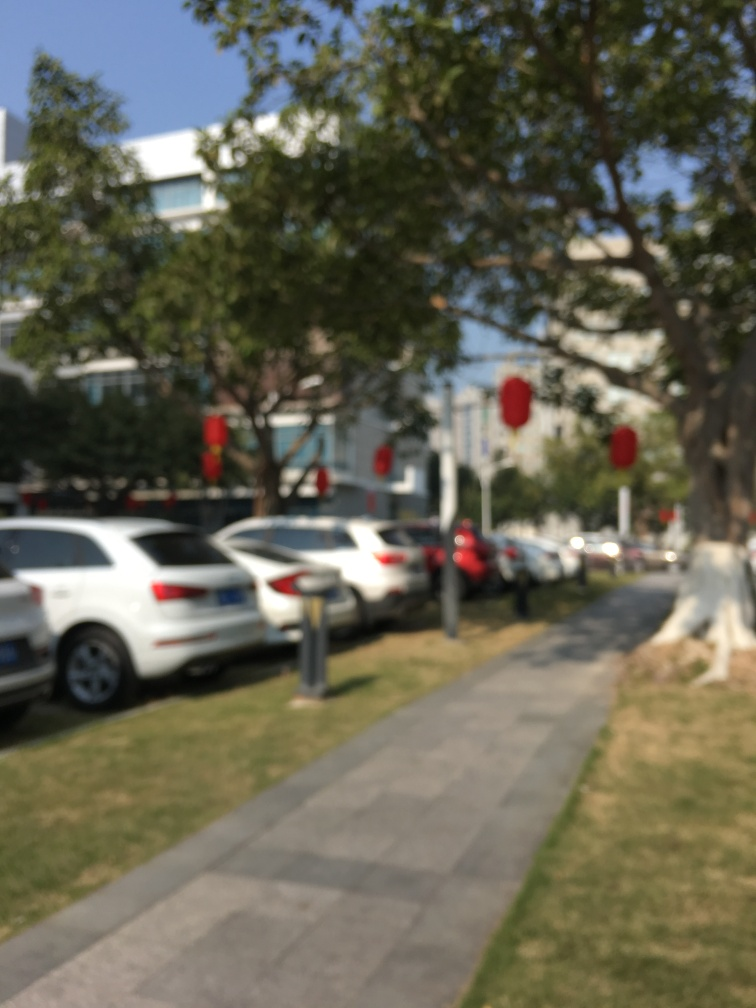Is the quality of the image poor? Yes, the quality of the image is poor due to its noticeable blurriness and lack of focus, which obscures details and makes it difficult to discern specific features of the scene. 